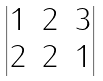Convert formula to latex. <formula><loc_0><loc_0><loc_500><loc_500>\begin{vmatrix} 1 & 2 & 3 \\ 2 & 2 & 1 \end{vmatrix}</formula> 